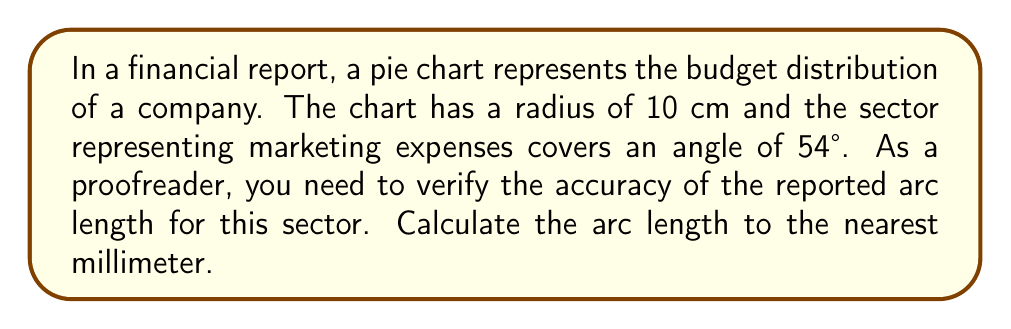Show me your answer to this math problem. To calculate the arc length of a circular sector, we use the formula:

$$ s = r \theta $$

Where:
$s$ = arc length
$r$ = radius of the circle
$\theta$ = angle in radians

Steps:
1) We have the radius $r = 10$ cm and the angle in degrees is 54°.

2) Convert the angle from degrees to radians:
   $\theta = 54° \times \frac{\pi}{180°} = 0.9425$ radians

3) Apply the arc length formula:
   $$ s = 10 \times 0.9425 = 9.425 \text{ cm} $$

4) Round to the nearest millimeter:
   $9.425 \text{ cm} = 94.25 \text{ mm} \approx 94.3 \text{ mm}$
Answer: 94.3 mm 